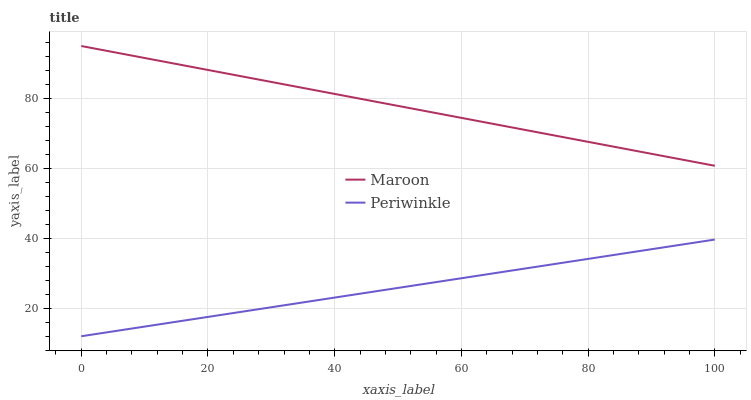Does Maroon have the minimum area under the curve?
Answer yes or no. No. Is Maroon the roughest?
Answer yes or no. No. Does Maroon have the lowest value?
Answer yes or no. No. Is Periwinkle less than Maroon?
Answer yes or no. Yes. Is Maroon greater than Periwinkle?
Answer yes or no. Yes. Does Periwinkle intersect Maroon?
Answer yes or no. No. 